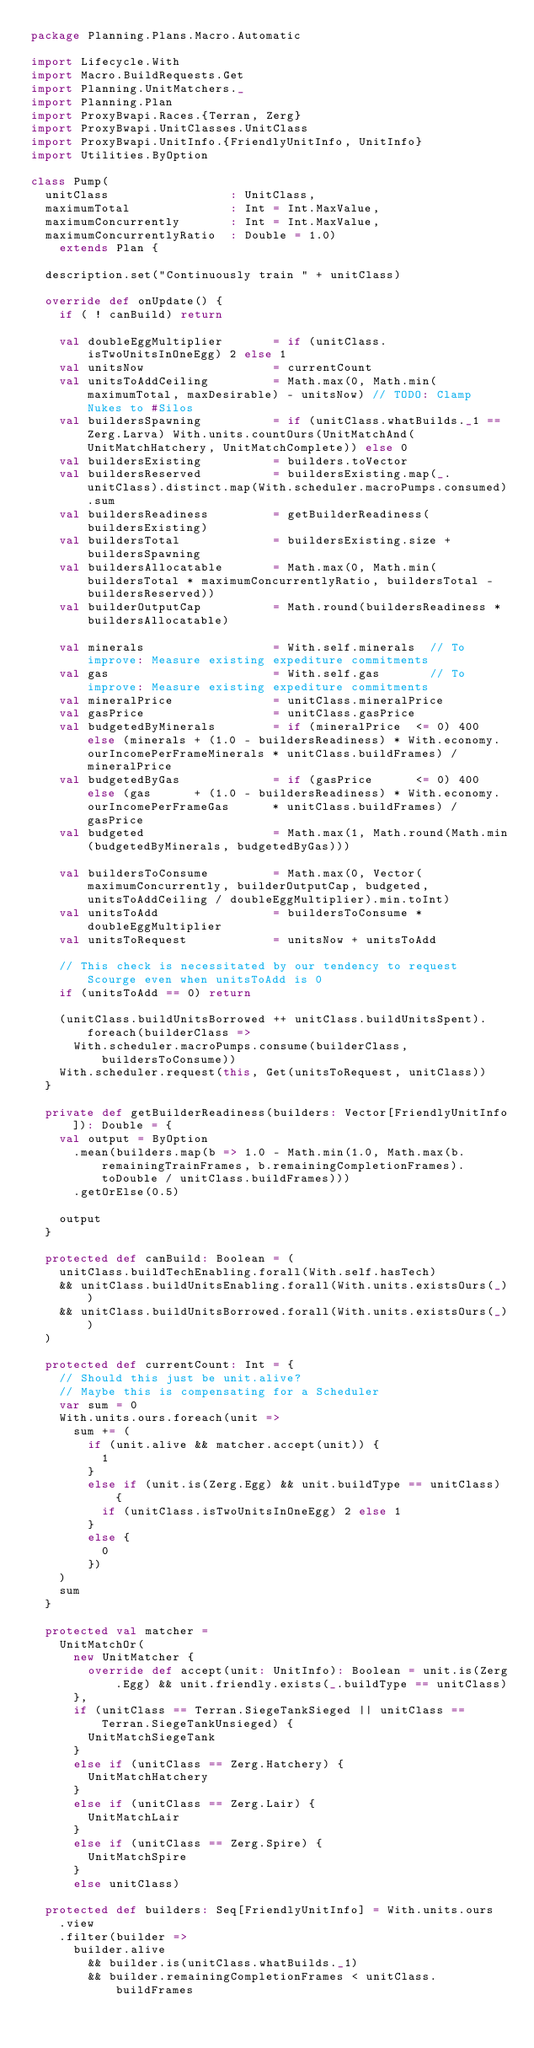Convert code to text. <code><loc_0><loc_0><loc_500><loc_500><_Scala_>package Planning.Plans.Macro.Automatic

import Lifecycle.With
import Macro.BuildRequests.Get
import Planning.UnitMatchers._
import Planning.Plan
import ProxyBwapi.Races.{Terran, Zerg}
import ProxyBwapi.UnitClasses.UnitClass
import ProxyBwapi.UnitInfo.{FriendlyUnitInfo, UnitInfo}
import Utilities.ByOption

class Pump(
  unitClass                 : UnitClass,
  maximumTotal              : Int = Int.MaxValue,
  maximumConcurrently       : Int = Int.MaxValue,
  maximumConcurrentlyRatio  : Double = 1.0)
    extends Plan {
    
  description.set("Continuously train " + unitClass)
  
  override def onUpdate() {
    if ( ! canBuild) return
  
    val doubleEggMultiplier       = if (unitClass.isTwoUnitsInOneEgg) 2 else 1
    val unitsNow                  = currentCount
    val unitsToAddCeiling         = Math.max(0, Math.min(maximumTotal, maxDesirable) - unitsNow) // TODO: Clamp Nukes to #Silos
    val buildersSpawning          = if (unitClass.whatBuilds._1 == Zerg.Larva) With.units.countOurs(UnitMatchAnd(UnitMatchHatchery, UnitMatchComplete)) else 0
    val buildersExisting          = builders.toVector
    val buildersReserved          = buildersExisting.map(_.unitClass).distinct.map(With.scheduler.macroPumps.consumed).sum
    val buildersReadiness         = getBuilderReadiness(buildersExisting)
    val buildersTotal             = buildersExisting.size + buildersSpawning
    val buildersAllocatable       = Math.max(0, Math.min(buildersTotal * maximumConcurrentlyRatio, buildersTotal - buildersReserved))
    val builderOutputCap          = Math.round(buildersReadiness * buildersAllocatable)
    
    val minerals                  = With.self.minerals  // To improve: Measure existing expediture commitments
    val gas                       = With.self.gas       // To improve: Measure existing expediture commitments
    val mineralPrice              = unitClass.mineralPrice
    val gasPrice                  = unitClass.gasPrice
    val budgetedByMinerals        = if (mineralPrice  <= 0) 400 else (minerals + (1.0 - buildersReadiness) * With.economy.ourIncomePerFrameMinerals * unitClass.buildFrames) / mineralPrice
    val budgetedByGas             = if (gasPrice      <= 0) 400 else (gas      + (1.0 - buildersReadiness) * With.economy.ourIncomePerFrameGas      * unitClass.buildFrames) / gasPrice
    val budgeted                  = Math.max(1, Math.round(Math.min(budgetedByMinerals, budgetedByGas)))
    
    val buildersToConsume         = Math.max(0, Vector(maximumConcurrently, builderOutputCap, budgeted, unitsToAddCeiling / doubleEggMultiplier).min.toInt)
    val unitsToAdd                = buildersToConsume * doubleEggMultiplier
    val unitsToRequest            = unitsNow + unitsToAdd
  
    // This check is necessitated by our tendency to request Scourge even when unitsToAdd is 0
    if (unitsToAdd == 0) return
    
    (unitClass.buildUnitsBorrowed ++ unitClass.buildUnitsSpent).foreach(builderClass =>
      With.scheduler.macroPumps.consume(builderClass, buildersToConsume))
    With.scheduler.request(this, Get(unitsToRequest, unitClass))
  }
  
  private def getBuilderReadiness(builders: Vector[FriendlyUnitInfo]): Double = {
    val output = ByOption
      .mean(builders.map(b => 1.0 - Math.min(1.0, Math.max(b.remainingTrainFrames, b.remainingCompletionFrames).toDouble / unitClass.buildFrames)))
      .getOrElse(0.5)
    
    output
  }
  
  protected def canBuild: Boolean = (
    unitClass.buildTechEnabling.forall(With.self.hasTech)
    && unitClass.buildUnitsEnabling.forall(With.units.existsOurs(_))
    && unitClass.buildUnitsBorrowed.forall(With.units.existsOurs(_))
  )
  
  protected def currentCount: Int = {
    // Should this just be unit.alive?
    // Maybe this is compensating for a Scheduler
    var sum = 0
    With.units.ours.foreach(unit =>
      sum += (
        if (unit.alive && matcher.accept(unit)) {
          1
        }
        else if (unit.is(Zerg.Egg) && unit.buildType == unitClass) {
          if (unitClass.isTwoUnitsInOneEgg) 2 else 1
        }
        else {
          0
        })
    )
    sum
  }
  
  protected val matcher =
    UnitMatchOr(
      new UnitMatcher {
        override def accept(unit: UnitInfo): Boolean = unit.is(Zerg.Egg) && unit.friendly.exists(_.buildType == unitClass)
      },
      if (unitClass == Terran.SiegeTankSieged || unitClass == Terran.SiegeTankUnsieged) {
        UnitMatchSiegeTank
      }
      else if (unitClass == Zerg.Hatchery) {
        UnitMatchHatchery
      }
      else if (unitClass == Zerg.Lair) {
        UnitMatchLair
      }
      else if (unitClass == Zerg.Spire) {
        UnitMatchSpire
      }
      else unitClass)
  
  protected def builders: Seq[FriendlyUnitInfo] = With.units.ours
    .view
    .filter(builder =>
      builder.alive
        && builder.is(unitClass.whatBuilds._1)
        && builder.remainingCompletionFrames < unitClass.buildFrames</code> 